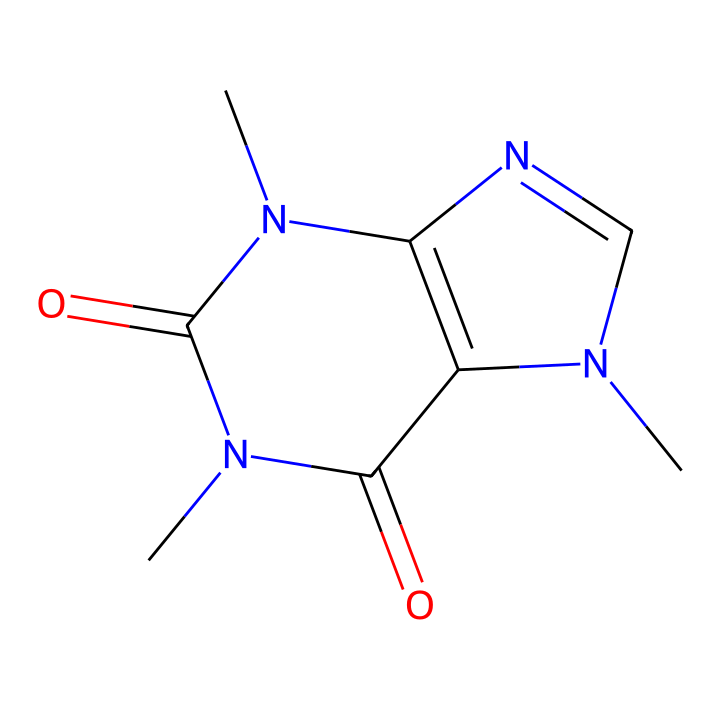What is the molecular formula of caffeine? To determine the molecular formula, count the number of each type of atom in the structural formula. From the SMILES, we can identify 8 carbon atoms, 10 hydrogen atoms, 4 nitrogen atoms, and 2 oxygen atoms. Thus, the molecular formula is C8H10N4O2.
Answer: C8H10N4O2 How many nitrogen atoms are present in caffeine? By observing the SMILES representation, we can see that there are 4 distinct nitrogen atoms present in the structure. Each 'N' in the formula represents one nitrogen atom.
Answer: 4 What functional groups are found in caffeine? The SMILES structure shows that caffeine contains two carbonyl (C=O) groups and multiple amine (–NH) links as part of the structure. The presence of these indicates the functional groups.
Answer: carbonyl, amine What type of compound is caffeine classified as? Caffeine is classified as a methylxanthine, which is a type of alkaloid that derives from xanthine. The nitrogen atoms in its structure confirm it as an alkaloid.
Answer: alkaloid How many rings are present in the caffeine structure? Analyzing the connectivity in the SMILES representation reveals a bicyclic structure consisting of two rings interconnected, making it a bicyclic compound.
Answer: 2 What characteristic property of caffeine is indicated by the presence of nitrogen atoms? The presence of multiple nitrogen atoms typically indicates basicity and potential for stimulating effects, which are characteristic properties of alkaloids like caffeine.
Answer: basicity 